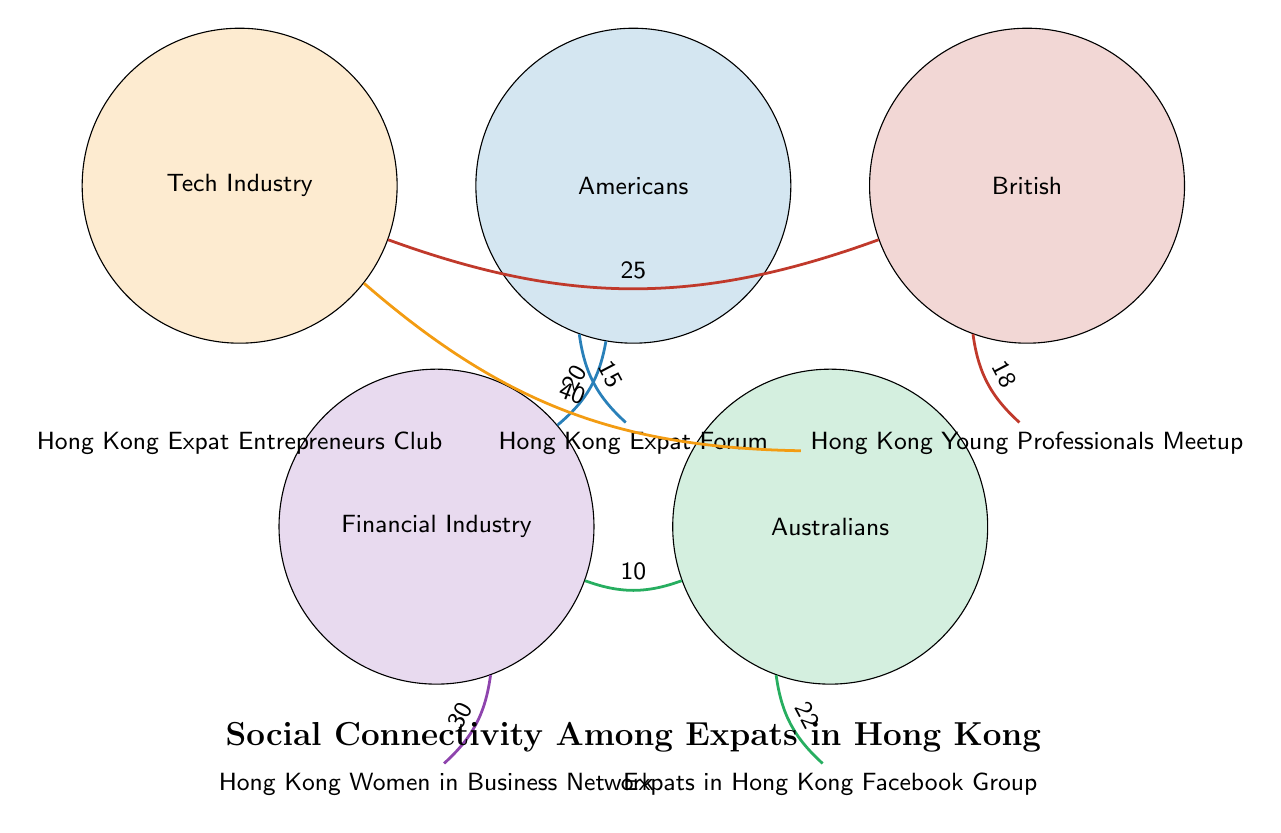What is the highest value link in the diagram? To find the highest value link, I review all connections drawn in the diagram. The links show the relationships between nodes, and I identify the values associated with them. The link from the Tech Industry to the 20-30 Age Group has the highest value of 40.
Answer: 40 Which age group is most connected to the Financial Industry? I analyze the connections coming from the Financial Industry node. The only age group linked is 30-40 Age Group with a value of 30. Therefore, this is the most connected age group.
Answer: 30-40 Age Group How many connections are there from Australians to social hubs? The Australians node has two connections: one to the Marketing Industry and one to the Expats in Hong Kong Facebook Group. Therefore, I count these connections directly.
Answer: 2 What nationality is most connected to the Hong Kong Young Professionals Meetup? To determine which nationality has the strongest connection to the Hong Kong Young Professionals Meetup, I check the links associated with this social hub. The British nationality has a link with a value of 18, which is greater than any other nationality's connections to this hub.
Answer: British Which industry has the least connections to age groups? I review the links to see how many connections each industry has to age groups. The Marketing Industry has only one connection with the 40-50 Age Group, while others have more connections to age groups. Therefore, the Marketing Industry has the least connections.
Answer: Marketing Industry What is the total number of nodes in the diagram? I count all unique nodes represented in the diagram. The nodes include nationalities, industries, age groups, and social hubs, totaling 13 distinct nodes.
Answer: 13 Which social hub is linked to both Australians and the 30-40 Age Group? Examining the connections, I note that the 30-40 Age Group has a link to the Hong Kong Women in Business Network and not directly to Australians. However, Australians link with the Expats in Hong Kong Facebook Group. Hence, there are no shared social hubs based on direct connections.
Answer: None How many links does the British nationality have? I look for all the connections emanating from the British node. There are two links: one to the Tech Industry and one to the Hong Kong Young Professionals Meetup, which I count directly.
Answer: 2 What is the connection value between Americans and the Hong Kong Expat Forum? I focus on the link from the Americans node to the Hong Kong Expat Forum. The value indicated for this link is 15, which directly answers the question.
Answer: 15 